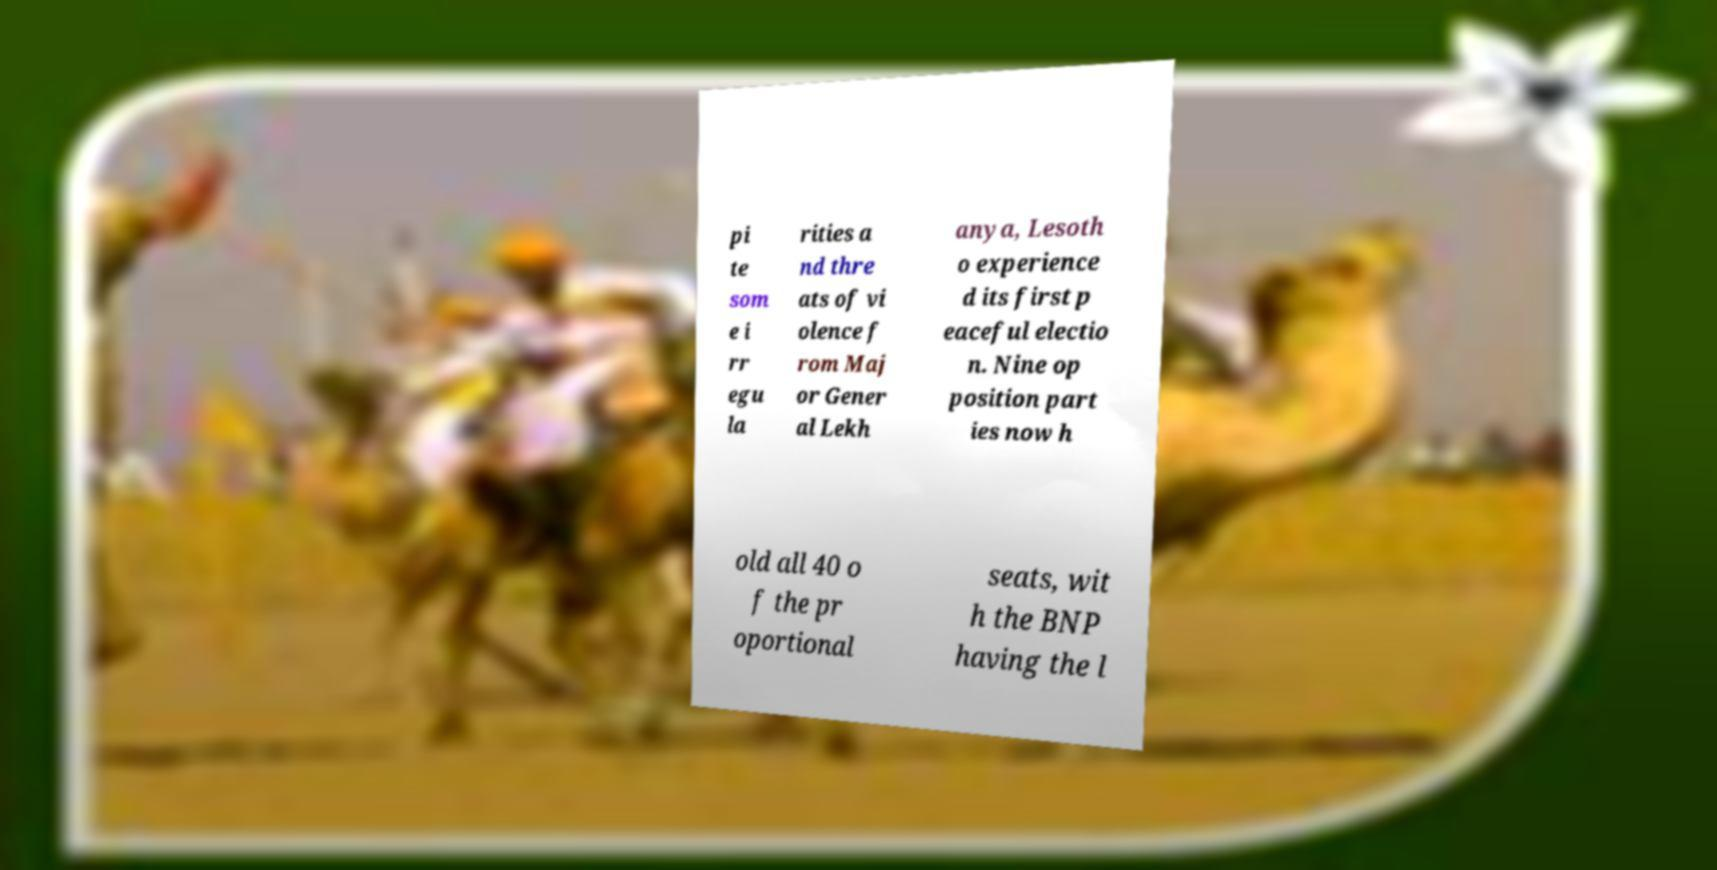Could you extract and type out the text from this image? pi te som e i rr egu la rities a nd thre ats of vi olence f rom Maj or Gener al Lekh anya, Lesoth o experience d its first p eaceful electio n. Nine op position part ies now h old all 40 o f the pr oportional seats, wit h the BNP having the l 